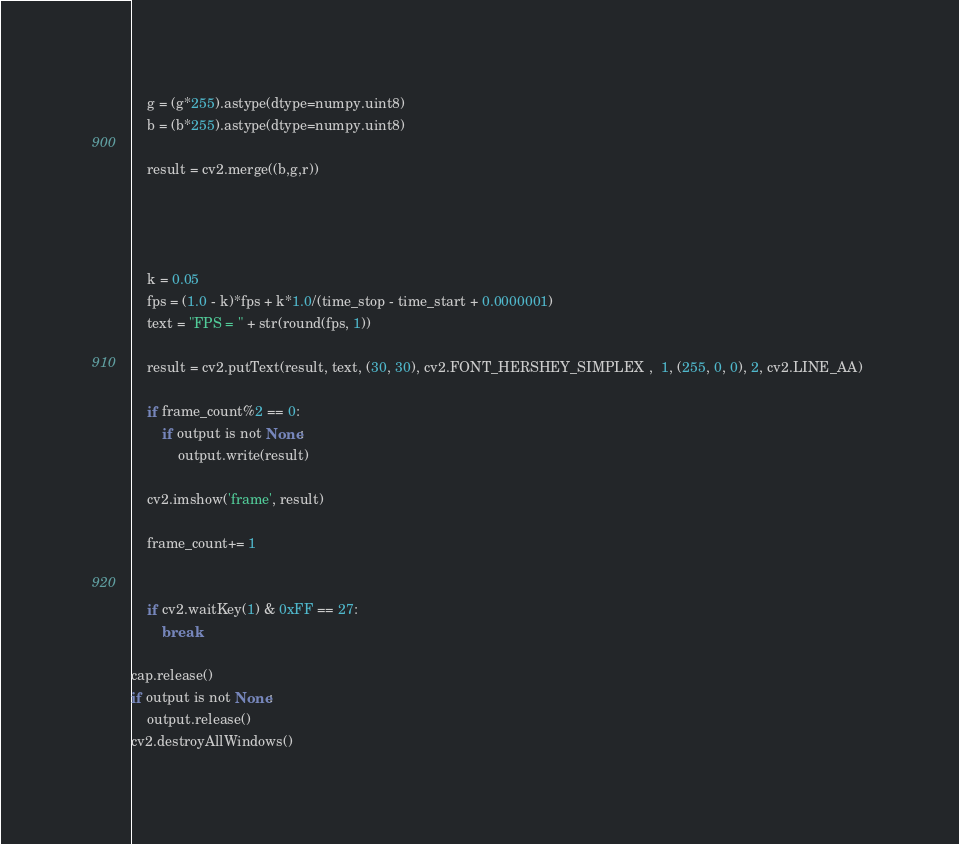Convert code to text. <code><loc_0><loc_0><loc_500><loc_500><_Python_>    g = (g*255).astype(dtype=numpy.uint8)
    b = (b*255).astype(dtype=numpy.uint8)

    result = cv2.merge((b,g,r))




    k = 0.05
    fps = (1.0 - k)*fps + k*1.0/(time_stop - time_start + 0.0000001)
    text = "FPS = " + str(round(fps, 1))

    result = cv2.putText(result, text, (30, 30), cv2.FONT_HERSHEY_SIMPLEX ,  1, (255, 0, 0), 2, cv2.LINE_AA) 

    if frame_count%2 == 0:
        if output is not None:
            output.write(result)

    cv2.imshow('frame', result)

    frame_count+= 1


    if cv2.waitKey(1) & 0xFF == 27:
        break

cap.release()
if output is not None:
    output.release()
cv2.destroyAllWindows()

</code> 